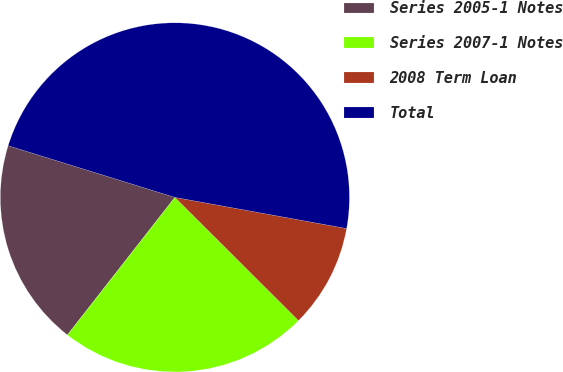Convert chart to OTSL. <chart><loc_0><loc_0><loc_500><loc_500><pie_chart><fcel>Series 2005-1 Notes<fcel>Series 2007-1 Notes<fcel>2008 Term Loan<fcel>Total<nl><fcel>19.23%<fcel>23.08%<fcel>9.62%<fcel>48.08%<nl></chart> 